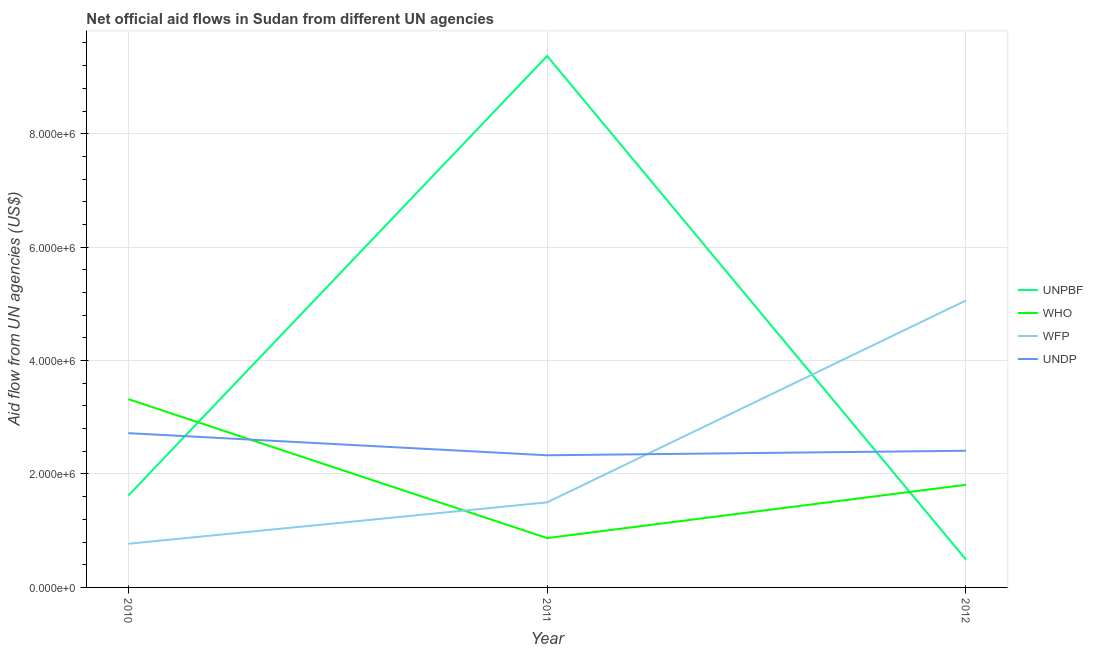What is the amount of aid given by undp in 2011?
Keep it short and to the point. 2.33e+06. Across all years, what is the maximum amount of aid given by unpbf?
Your answer should be very brief. 9.37e+06. Across all years, what is the minimum amount of aid given by undp?
Your answer should be compact. 2.33e+06. In which year was the amount of aid given by who minimum?
Your answer should be very brief. 2011. What is the total amount of aid given by wfp in the graph?
Give a very brief answer. 7.33e+06. What is the difference between the amount of aid given by unpbf in 2010 and that in 2012?
Provide a short and direct response. 1.13e+06. What is the difference between the amount of aid given by undp in 2011 and the amount of aid given by who in 2010?
Offer a terse response. -9.90e+05. In the year 2011, what is the difference between the amount of aid given by unpbf and amount of aid given by wfp?
Provide a succinct answer. 7.87e+06. What is the ratio of the amount of aid given by wfp in 2010 to that in 2012?
Offer a terse response. 0.15. Is the amount of aid given by undp in 2010 less than that in 2011?
Keep it short and to the point. No. What is the difference between the highest and the second highest amount of aid given by wfp?
Offer a very short reply. 3.56e+06. What is the difference between the highest and the lowest amount of aid given by undp?
Give a very brief answer. 3.90e+05. Does the amount of aid given by unpbf monotonically increase over the years?
Your answer should be compact. No. Is the amount of aid given by who strictly greater than the amount of aid given by undp over the years?
Provide a short and direct response. No. Is the amount of aid given by undp strictly less than the amount of aid given by unpbf over the years?
Keep it short and to the point. No. How many years are there in the graph?
Make the answer very short. 3. What is the difference between two consecutive major ticks on the Y-axis?
Keep it short and to the point. 2.00e+06. How many legend labels are there?
Keep it short and to the point. 4. How are the legend labels stacked?
Give a very brief answer. Vertical. What is the title of the graph?
Keep it short and to the point. Net official aid flows in Sudan from different UN agencies. Does "France" appear as one of the legend labels in the graph?
Give a very brief answer. No. What is the label or title of the X-axis?
Provide a succinct answer. Year. What is the label or title of the Y-axis?
Your answer should be very brief. Aid flow from UN agencies (US$). What is the Aid flow from UN agencies (US$) in UNPBF in 2010?
Your answer should be compact. 1.62e+06. What is the Aid flow from UN agencies (US$) of WHO in 2010?
Keep it short and to the point. 3.32e+06. What is the Aid flow from UN agencies (US$) in WFP in 2010?
Provide a succinct answer. 7.70e+05. What is the Aid flow from UN agencies (US$) of UNDP in 2010?
Provide a succinct answer. 2.72e+06. What is the Aid flow from UN agencies (US$) of UNPBF in 2011?
Provide a succinct answer. 9.37e+06. What is the Aid flow from UN agencies (US$) in WHO in 2011?
Offer a very short reply. 8.70e+05. What is the Aid flow from UN agencies (US$) in WFP in 2011?
Give a very brief answer. 1.50e+06. What is the Aid flow from UN agencies (US$) of UNDP in 2011?
Make the answer very short. 2.33e+06. What is the Aid flow from UN agencies (US$) in UNPBF in 2012?
Ensure brevity in your answer.  4.90e+05. What is the Aid flow from UN agencies (US$) of WHO in 2012?
Ensure brevity in your answer.  1.81e+06. What is the Aid flow from UN agencies (US$) in WFP in 2012?
Keep it short and to the point. 5.06e+06. What is the Aid flow from UN agencies (US$) in UNDP in 2012?
Provide a short and direct response. 2.41e+06. Across all years, what is the maximum Aid flow from UN agencies (US$) of UNPBF?
Provide a succinct answer. 9.37e+06. Across all years, what is the maximum Aid flow from UN agencies (US$) in WHO?
Your answer should be very brief. 3.32e+06. Across all years, what is the maximum Aid flow from UN agencies (US$) in WFP?
Offer a very short reply. 5.06e+06. Across all years, what is the maximum Aid flow from UN agencies (US$) of UNDP?
Your response must be concise. 2.72e+06. Across all years, what is the minimum Aid flow from UN agencies (US$) in UNPBF?
Your answer should be very brief. 4.90e+05. Across all years, what is the minimum Aid flow from UN agencies (US$) of WHO?
Ensure brevity in your answer.  8.70e+05. Across all years, what is the minimum Aid flow from UN agencies (US$) of WFP?
Offer a very short reply. 7.70e+05. Across all years, what is the minimum Aid flow from UN agencies (US$) in UNDP?
Your response must be concise. 2.33e+06. What is the total Aid flow from UN agencies (US$) of UNPBF in the graph?
Your answer should be very brief. 1.15e+07. What is the total Aid flow from UN agencies (US$) in WFP in the graph?
Offer a very short reply. 7.33e+06. What is the total Aid flow from UN agencies (US$) in UNDP in the graph?
Provide a short and direct response. 7.46e+06. What is the difference between the Aid flow from UN agencies (US$) in UNPBF in 2010 and that in 2011?
Ensure brevity in your answer.  -7.75e+06. What is the difference between the Aid flow from UN agencies (US$) of WHO in 2010 and that in 2011?
Give a very brief answer. 2.45e+06. What is the difference between the Aid flow from UN agencies (US$) in WFP in 2010 and that in 2011?
Provide a succinct answer. -7.30e+05. What is the difference between the Aid flow from UN agencies (US$) of UNPBF in 2010 and that in 2012?
Your response must be concise. 1.13e+06. What is the difference between the Aid flow from UN agencies (US$) in WHO in 2010 and that in 2012?
Offer a very short reply. 1.51e+06. What is the difference between the Aid flow from UN agencies (US$) of WFP in 2010 and that in 2012?
Ensure brevity in your answer.  -4.29e+06. What is the difference between the Aid flow from UN agencies (US$) of UNPBF in 2011 and that in 2012?
Your answer should be very brief. 8.88e+06. What is the difference between the Aid flow from UN agencies (US$) of WHO in 2011 and that in 2012?
Ensure brevity in your answer.  -9.40e+05. What is the difference between the Aid flow from UN agencies (US$) in WFP in 2011 and that in 2012?
Your answer should be very brief. -3.56e+06. What is the difference between the Aid flow from UN agencies (US$) of UNPBF in 2010 and the Aid flow from UN agencies (US$) of WHO in 2011?
Your answer should be very brief. 7.50e+05. What is the difference between the Aid flow from UN agencies (US$) in UNPBF in 2010 and the Aid flow from UN agencies (US$) in UNDP in 2011?
Provide a short and direct response. -7.10e+05. What is the difference between the Aid flow from UN agencies (US$) of WHO in 2010 and the Aid flow from UN agencies (US$) of WFP in 2011?
Provide a short and direct response. 1.82e+06. What is the difference between the Aid flow from UN agencies (US$) of WHO in 2010 and the Aid flow from UN agencies (US$) of UNDP in 2011?
Give a very brief answer. 9.90e+05. What is the difference between the Aid flow from UN agencies (US$) in WFP in 2010 and the Aid flow from UN agencies (US$) in UNDP in 2011?
Keep it short and to the point. -1.56e+06. What is the difference between the Aid flow from UN agencies (US$) of UNPBF in 2010 and the Aid flow from UN agencies (US$) of WHO in 2012?
Provide a succinct answer. -1.90e+05. What is the difference between the Aid flow from UN agencies (US$) in UNPBF in 2010 and the Aid flow from UN agencies (US$) in WFP in 2012?
Offer a terse response. -3.44e+06. What is the difference between the Aid flow from UN agencies (US$) of UNPBF in 2010 and the Aid flow from UN agencies (US$) of UNDP in 2012?
Give a very brief answer. -7.90e+05. What is the difference between the Aid flow from UN agencies (US$) in WHO in 2010 and the Aid flow from UN agencies (US$) in WFP in 2012?
Keep it short and to the point. -1.74e+06. What is the difference between the Aid flow from UN agencies (US$) in WHO in 2010 and the Aid flow from UN agencies (US$) in UNDP in 2012?
Offer a very short reply. 9.10e+05. What is the difference between the Aid flow from UN agencies (US$) of WFP in 2010 and the Aid flow from UN agencies (US$) of UNDP in 2012?
Make the answer very short. -1.64e+06. What is the difference between the Aid flow from UN agencies (US$) of UNPBF in 2011 and the Aid flow from UN agencies (US$) of WHO in 2012?
Offer a very short reply. 7.56e+06. What is the difference between the Aid flow from UN agencies (US$) of UNPBF in 2011 and the Aid flow from UN agencies (US$) of WFP in 2012?
Provide a succinct answer. 4.31e+06. What is the difference between the Aid flow from UN agencies (US$) in UNPBF in 2011 and the Aid flow from UN agencies (US$) in UNDP in 2012?
Your answer should be compact. 6.96e+06. What is the difference between the Aid flow from UN agencies (US$) in WHO in 2011 and the Aid flow from UN agencies (US$) in WFP in 2012?
Offer a very short reply. -4.19e+06. What is the difference between the Aid flow from UN agencies (US$) in WHO in 2011 and the Aid flow from UN agencies (US$) in UNDP in 2012?
Give a very brief answer. -1.54e+06. What is the difference between the Aid flow from UN agencies (US$) of WFP in 2011 and the Aid flow from UN agencies (US$) of UNDP in 2012?
Provide a short and direct response. -9.10e+05. What is the average Aid flow from UN agencies (US$) of UNPBF per year?
Provide a succinct answer. 3.83e+06. What is the average Aid flow from UN agencies (US$) in WHO per year?
Offer a terse response. 2.00e+06. What is the average Aid flow from UN agencies (US$) of WFP per year?
Provide a short and direct response. 2.44e+06. What is the average Aid flow from UN agencies (US$) of UNDP per year?
Provide a succinct answer. 2.49e+06. In the year 2010, what is the difference between the Aid flow from UN agencies (US$) of UNPBF and Aid flow from UN agencies (US$) of WHO?
Ensure brevity in your answer.  -1.70e+06. In the year 2010, what is the difference between the Aid flow from UN agencies (US$) of UNPBF and Aid flow from UN agencies (US$) of WFP?
Keep it short and to the point. 8.50e+05. In the year 2010, what is the difference between the Aid flow from UN agencies (US$) of UNPBF and Aid flow from UN agencies (US$) of UNDP?
Provide a short and direct response. -1.10e+06. In the year 2010, what is the difference between the Aid flow from UN agencies (US$) of WHO and Aid flow from UN agencies (US$) of WFP?
Your answer should be compact. 2.55e+06. In the year 2010, what is the difference between the Aid flow from UN agencies (US$) in WFP and Aid flow from UN agencies (US$) in UNDP?
Keep it short and to the point. -1.95e+06. In the year 2011, what is the difference between the Aid flow from UN agencies (US$) in UNPBF and Aid flow from UN agencies (US$) in WHO?
Your answer should be compact. 8.50e+06. In the year 2011, what is the difference between the Aid flow from UN agencies (US$) of UNPBF and Aid flow from UN agencies (US$) of WFP?
Your response must be concise. 7.87e+06. In the year 2011, what is the difference between the Aid flow from UN agencies (US$) in UNPBF and Aid flow from UN agencies (US$) in UNDP?
Offer a very short reply. 7.04e+06. In the year 2011, what is the difference between the Aid flow from UN agencies (US$) in WHO and Aid flow from UN agencies (US$) in WFP?
Your answer should be compact. -6.30e+05. In the year 2011, what is the difference between the Aid flow from UN agencies (US$) in WHO and Aid flow from UN agencies (US$) in UNDP?
Make the answer very short. -1.46e+06. In the year 2011, what is the difference between the Aid flow from UN agencies (US$) of WFP and Aid flow from UN agencies (US$) of UNDP?
Your response must be concise. -8.30e+05. In the year 2012, what is the difference between the Aid flow from UN agencies (US$) of UNPBF and Aid flow from UN agencies (US$) of WHO?
Your answer should be compact. -1.32e+06. In the year 2012, what is the difference between the Aid flow from UN agencies (US$) in UNPBF and Aid flow from UN agencies (US$) in WFP?
Your answer should be very brief. -4.57e+06. In the year 2012, what is the difference between the Aid flow from UN agencies (US$) in UNPBF and Aid flow from UN agencies (US$) in UNDP?
Ensure brevity in your answer.  -1.92e+06. In the year 2012, what is the difference between the Aid flow from UN agencies (US$) in WHO and Aid flow from UN agencies (US$) in WFP?
Ensure brevity in your answer.  -3.25e+06. In the year 2012, what is the difference between the Aid flow from UN agencies (US$) of WHO and Aid flow from UN agencies (US$) of UNDP?
Give a very brief answer. -6.00e+05. In the year 2012, what is the difference between the Aid flow from UN agencies (US$) in WFP and Aid flow from UN agencies (US$) in UNDP?
Keep it short and to the point. 2.65e+06. What is the ratio of the Aid flow from UN agencies (US$) in UNPBF in 2010 to that in 2011?
Make the answer very short. 0.17. What is the ratio of the Aid flow from UN agencies (US$) in WHO in 2010 to that in 2011?
Offer a very short reply. 3.82. What is the ratio of the Aid flow from UN agencies (US$) of WFP in 2010 to that in 2011?
Your response must be concise. 0.51. What is the ratio of the Aid flow from UN agencies (US$) in UNDP in 2010 to that in 2011?
Keep it short and to the point. 1.17. What is the ratio of the Aid flow from UN agencies (US$) of UNPBF in 2010 to that in 2012?
Make the answer very short. 3.31. What is the ratio of the Aid flow from UN agencies (US$) in WHO in 2010 to that in 2012?
Provide a short and direct response. 1.83. What is the ratio of the Aid flow from UN agencies (US$) of WFP in 2010 to that in 2012?
Offer a terse response. 0.15. What is the ratio of the Aid flow from UN agencies (US$) of UNDP in 2010 to that in 2012?
Ensure brevity in your answer.  1.13. What is the ratio of the Aid flow from UN agencies (US$) of UNPBF in 2011 to that in 2012?
Provide a succinct answer. 19.12. What is the ratio of the Aid flow from UN agencies (US$) in WHO in 2011 to that in 2012?
Make the answer very short. 0.48. What is the ratio of the Aid flow from UN agencies (US$) of WFP in 2011 to that in 2012?
Offer a terse response. 0.3. What is the ratio of the Aid flow from UN agencies (US$) in UNDP in 2011 to that in 2012?
Provide a succinct answer. 0.97. What is the difference between the highest and the second highest Aid flow from UN agencies (US$) of UNPBF?
Keep it short and to the point. 7.75e+06. What is the difference between the highest and the second highest Aid flow from UN agencies (US$) in WHO?
Provide a short and direct response. 1.51e+06. What is the difference between the highest and the second highest Aid flow from UN agencies (US$) in WFP?
Offer a very short reply. 3.56e+06. What is the difference between the highest and the second highest Aid flow from UN agencies (US$) of UNDP?
Provide a short and direct response. 3.10e+05. What is the difference between the highest and the lowest Aid flow from UN agencies (US$) in UNPBF?
Make the answer very short. 8.88e+06. What is the difference between the highest and the lowest Aid flow from UN agencies (US$) of WHO?
Give a very brief answer. 2.45e+06. What is the difference between the highest and the lowest Aid flow from UN agencies (US$) in WFP?
Offer a terse response. 4.29e+06. What is the difference between the highest and the lowest Aid flow from UN agencies (US$) in UNDP?
Make the answer very short. 3.90e+05. 